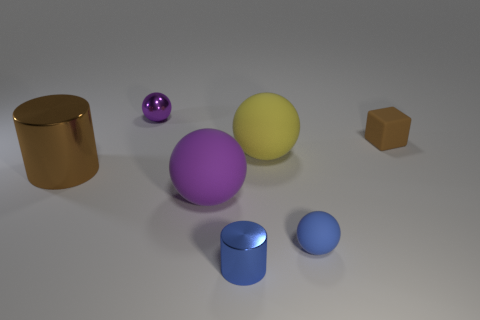Subtract all tiny purple balls. How many balls are left? 3 Subtract all brown cylinders. How many cylinders are left? 1 Add 1 metallic spheres. How many objects exist? 8 Subtract 3 spheres. How many spheres are left? 1 Subtract 0 gray blocks. How many objects are left? 7 Subtract all cylinders. How many objects are left? 5 Subtract all blue cylinders. Subtract all cyan balls. How many cylinders are left? 1 Subtract all cyan spheres. How many blue cylinders are left? 1 Subtract all big metal cylinders. Subtract all big cylinders. How many objects are left? 5 Add 1 brown rubber objects. How many brown rubber objects are left? 2 